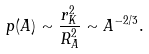<formula> <loc_0><loc_0><loc_500><loc_500>p ( A ) \sim \frac { r _ { K } ^ { 2 } } { R _ { A } ^ { 2 } } \sim A ^ { - 2 / 3 } .</formula> 